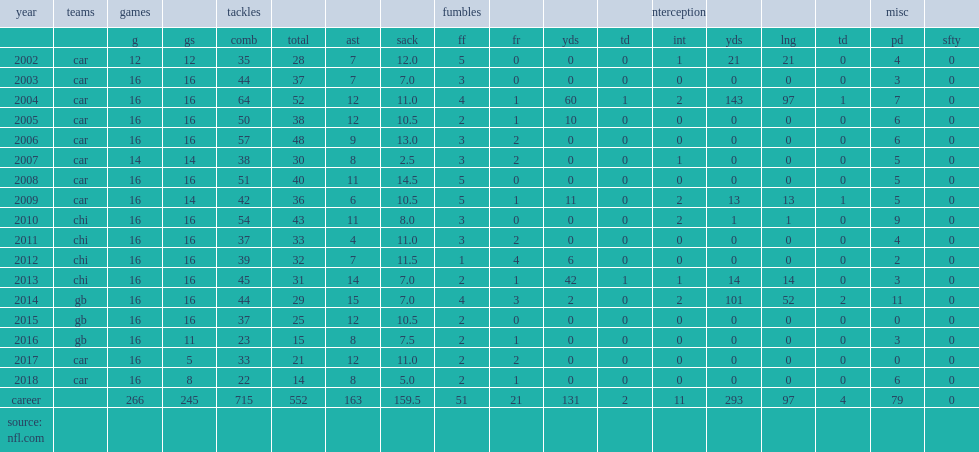How many games did julius peppers play in his career? 266.0. Give me the full table as a dictionary. {'header': ['year', 'teams', 'games', '', 'tackles', '', '', '', 'fumbles', '', '', '', 'interceptions', '', '', '', 'misc', ''], 'rows': [['', '', 'g', 'gs', 'comb', 'total', 'ast', 'sack', 'ff', 'fr', 'yds', 'td', 'int', 'yds', 'lng', 'td', 'pd', 'sfty'], ['2002', 'car', '12', '12', '35', '28', '7', '12.0', '5', '0', '0', '0', '1', '21', '21', '0', '4', '0'], ['2003', 'car', '16', '16', '44', '37', '7', '7.0', '3', '0', '0', '0', '0', '0', '0', '0', '3', '0'], ['2004', 'car', '16', '16', '64', '52', '12', '11.0', '4', '1', '60', '1', '2', '143', '97', '1', '7', '0'], ['2005', 'car', '16', '16', '50', '38', '12', '10.5', '2', '1', '10', '0', '0', '0', '0', '0', '6', '0'], ['2006', 'car', '16', '16', '57', '48', '9', '13.0', '3', '2', '0', '0', '0', '0', '0', '0', '6', '0'], ['2007', 'car', '14', '14', '38', '30', '8', '2.5', '3', '2', '0', '0', '1', '0', '0', '0', '5', '0'], ['2008', 'car', '16', '16', '51', '40', '11', '14.5', '5', '0', '0', '0', '0', '0', '0', '0', '5', '0'], ['2009', 'car', '16', '14', '42', '36', '6', '10.5', '5', '1', '11', '0', '2', '13', '13', '1', '5', '0'], ['2010', 'chi', '16', '16', '54', '43', '11', '8.0', '3', '0', '0', '0', '2', '1', '1', '0', '9', '0'], ['2011', 'chi', '16', '16', '37', '33', '4', '11.0', '3', '2', '0', '0', '0', '0', '0', '0', '4', '0'], ['2012', 'chi', '16', '16', '39', '32', '7', '11.5', '1', '4', '6', '0', '0', '0', '0', '0', '2', '0'], ['2013', 'chi', '16', '16', '45', '31', '14', '7.0', '2', '1', '42', '1', '1', '14', '14', '0', '3', '0'], ['2014', 'gb', '16', '16', '44', '29', '15', '7.0', '4', '3', '2', '0', '2', '101', '52', '2', '11', '0'], ['2015', 'gb', '16', '16', '37', '25', '12', '10.5', '2', '0', '0', '0', '0', '0', '0', '0', '0', '0'], ['2016', 'gb', '16', '11', '23', '15', '8', '7.5', '2', '1', '0', '0', '0', '0', '0', '0', '3', '0'], ['2017', 'car', '16', '5', '33', '21', '12', '11.0', '2', '2', '0', '0', '0', '0', '0', '0', '0', '0'], ['2018', 'car', '16', '8', '22', '14', '8', '5.0', '2', '1', '0', '0', '0', '0', '0', '0', '6', '0'], ['career', '', '266', '245', '715', '552', '163', '159.5', '51', '21', '131', '2', '11', '293', '97', '4', '79', '0'], ['source: nfl.com', '', '', '', '', '', '', '', '', '', '', '', '', '', '', '', '', '']]} 